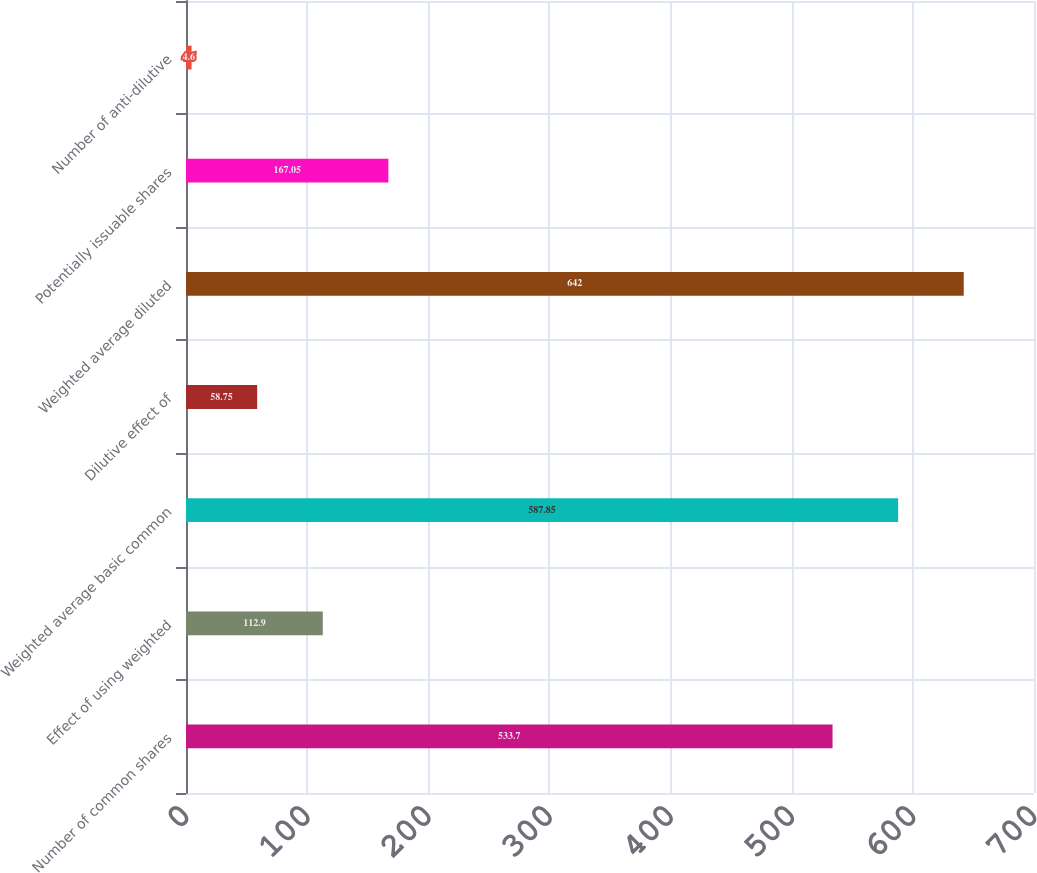<chart> <loc_0><loc_0><loc_500><loc_500><bar_chart><fcel>Number of common shares<fcel>Effect of using weighted<fcel>Weighted average basic common<fcel>Dilutive effect of<fcel>Weighted average diluted<fcel>Potentially issuable shares<fcel>Number of anti-dilutive<nl><fcel>533.7<fcel>112.9<fcel>587.85<fcel>58.75<fcel>642<fcel>167.05<fcel>4.6<nl></chart> 